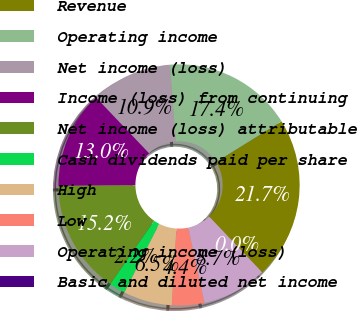Convert chart to OTSL. <chart><loc_0><loc_0><loc_500><loc_500><pie_chart><fcel>Revenue<fcel>Operating income<fcel>Net income (loss)<fcel>Income (loss) from continuing<fcel>Net income (loss) attributable<fcel>Cash dividends paid per share<fcel>High<fcel>Low<fcel>Operating income (loss)<fcel>Basic and diluted net income<nl><fcel>21.74%<fcel>17.39%<fcel>10.87%<fcel>13.04%<fcel>15.22%<fcel>2.17%<fcel>6.52%<fcel>4.35%<fcel>8.7%<fcel>0.0%<nl></chart> 